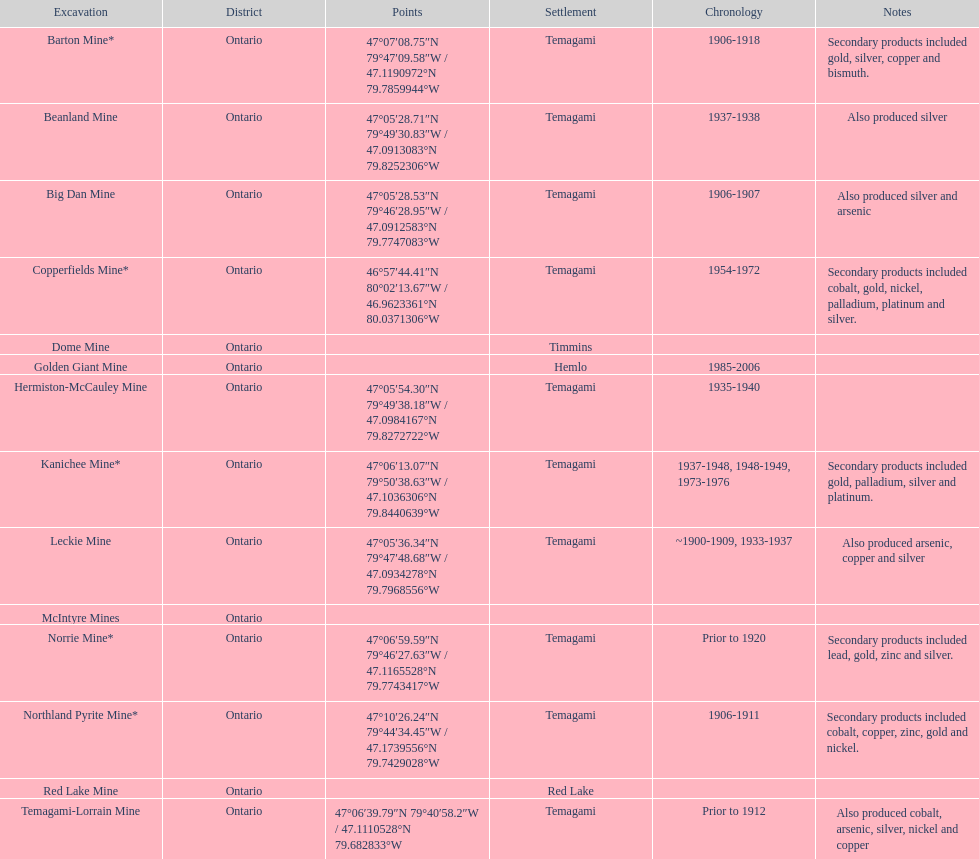What province is the town of temagami? Ontario. Write the full table. {'header': ['Excavation', 'District', 'Points', 'Settlement', 'Chronology', 'Notes'], 'rows': [['Barton Mine*', 'Ontario', '47°07′08.75″N 79°47′09.58″W\ufeff / \ufeff47.1190972°N 79.7859944°W', 'Temagami', '1906-1918', 'Secondary products included gold, silver, copper and bismuth.'], ['Beanland Mine', 'Ontario', '47°05′28.71″N 79°49′30.83″W\ufeff / \ufeff47.0913083°N 79.8252306°W', 'Temagami', '1937-1938', 'Also produced silver'], ['Big Dan Mine', 'Ontario', '47°05′28.53″N 79°46′28.95″W\ufeff / \ufeff47.0912583°N 79.7747083°W', 'Temagami', '1906-1907', 'Also produced silver and arsenic'], ['Copperfields Mine*', 'Ontario', '46°57′44.41″N 80°02′13.67″W\ufeff / \ufeff46.9623361°N 80.0371306°W', 'Temagami', '1954-1972', 'Secondary products included cobalt, gold, nickel, palladium, platinum and silver.'], ['Dome Mine', 'Ontario', '', 'Timmins', '', ''], ['Golden Giant Mine', 'Ontario', '', 'Hemlo', '1985-2006', ''], ['Hermiston-McCauley Mine', 'Ontario', '47°05′54.30″N 79°49′38.18″W\ufeff / \ufeff47.0984167°N 79.8272722°W', 'Temagami', '1935-1940', ''], ['Kanichee Mine*', 'Ontario', '47°06′13.07″N 79°50′38.63″W\ufeff / \ufeff47.1036306°N 79.8440639°W', 'Temagami', '1937-1948, 1948-1949, 1973-1976', 'Secondary products included gold, palladium, silver and platinum.'], ['Leckie Mine', 'Ontario', '47°05′36.34″N 79°47′48.68″W\ufeff / \ufeff47.0934278°N 79.7968556°W', 'Temagami', '~1900-1909, 1933-1937', 'Also produced arsenic, copper and silver'], ['McIntyre Mines', 'Ontario', '', '', '', ''], ['Norrie Mine*', 'Ontario', '47°06′59.59″N 79°46′27.63″W\ufeff / \ufeff47.1165528°N 79.7743417°W', 'Temagami', 'Prior to 1920', 'Secondary products included lead, gold, zinc and silver.'], ['Northland Pyrite Mine*', 'Ontario', '47°10′26.24″N 79°44′34.45″W\ufeff / \ufeff47.1739556°N 79.7429028°W', 'Temagami', '1906-1911', 'Secondary products included cobalt, copper, zinc, gold and nickel.'], ['Red Lake Mine', 'Ontario', '', 'Red Lake', '', ''], ['Temagami-Lorrain Mine', 'Ontario', '47°06′39.79″N 79°40′58.2″W\ufeff / \ufeff47.1110528°N 79.682833°W', 'Temagami', 'Prior to 1912', 'Also produced cobalt, arsenic, silver, nickel and copper']]} 